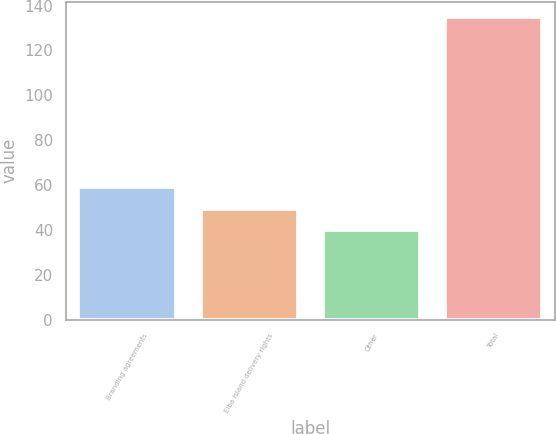Convert chart to OTSL. <chart><loc_0><loc_0><loc_500><loc_500><bar_chart><fcel>Branding agreements<fcel>Elba Island delivery rights<fcel>Other<fcel>Total<nl><fcel>59<fcel>49.5<fcel>40<fcel>135<nl></chart> 